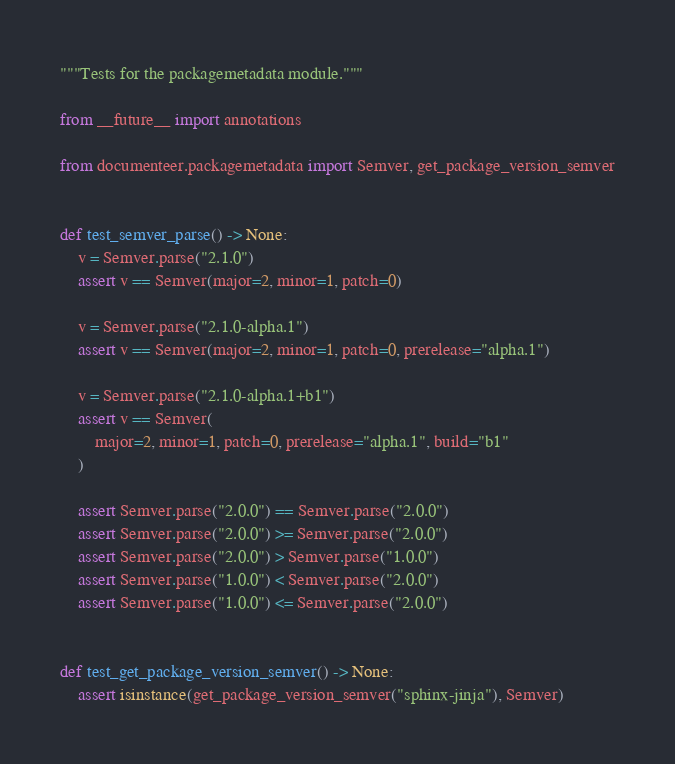Convert code to text. <code><loc_0><loc_0><loc_500><loc_500><_Python_>"""Tests for the packagemetadata module."""

from __future__ import annotations

from documenteer.packagemetadata import Semver, get_package_version_semver


def test_semver_parse() -> None:
    v = Semver.parse("2.1.0")
    assert v == Semver(major=2, minor=1, patch=0)

    v = Semver.parse("2.1.0-alpha.1")
    assert v == Semver(major=2, minor=1, patch=0, prerelease="alpha.1")

    v = Semver.parse("2.1.0-alpha.1+b1")
    assert v == Semver(
        major=2, minor=1, patch=0, prerelease="alpha.1", build="b1"
    )

    assert Semver.parse("2.0.0") == Semver.parse("2.0.0")
    assert Semver.parse("2.0.0") >= Semver.parse("2.0.0")
    assert Semver.parse("2.0.0") > Semver.parse("1.0.0")
    assert Semver.parse("1.0.0") < Semver.parse("2.0.0")
    assert Semver.parse("1.0.0") <= Semver.parse("2.0.0")


def test_get_package_version_semver() -> None:
    assert isinstance(get_package_version_semver("sphinx-jinja"), Semver)
</code> 